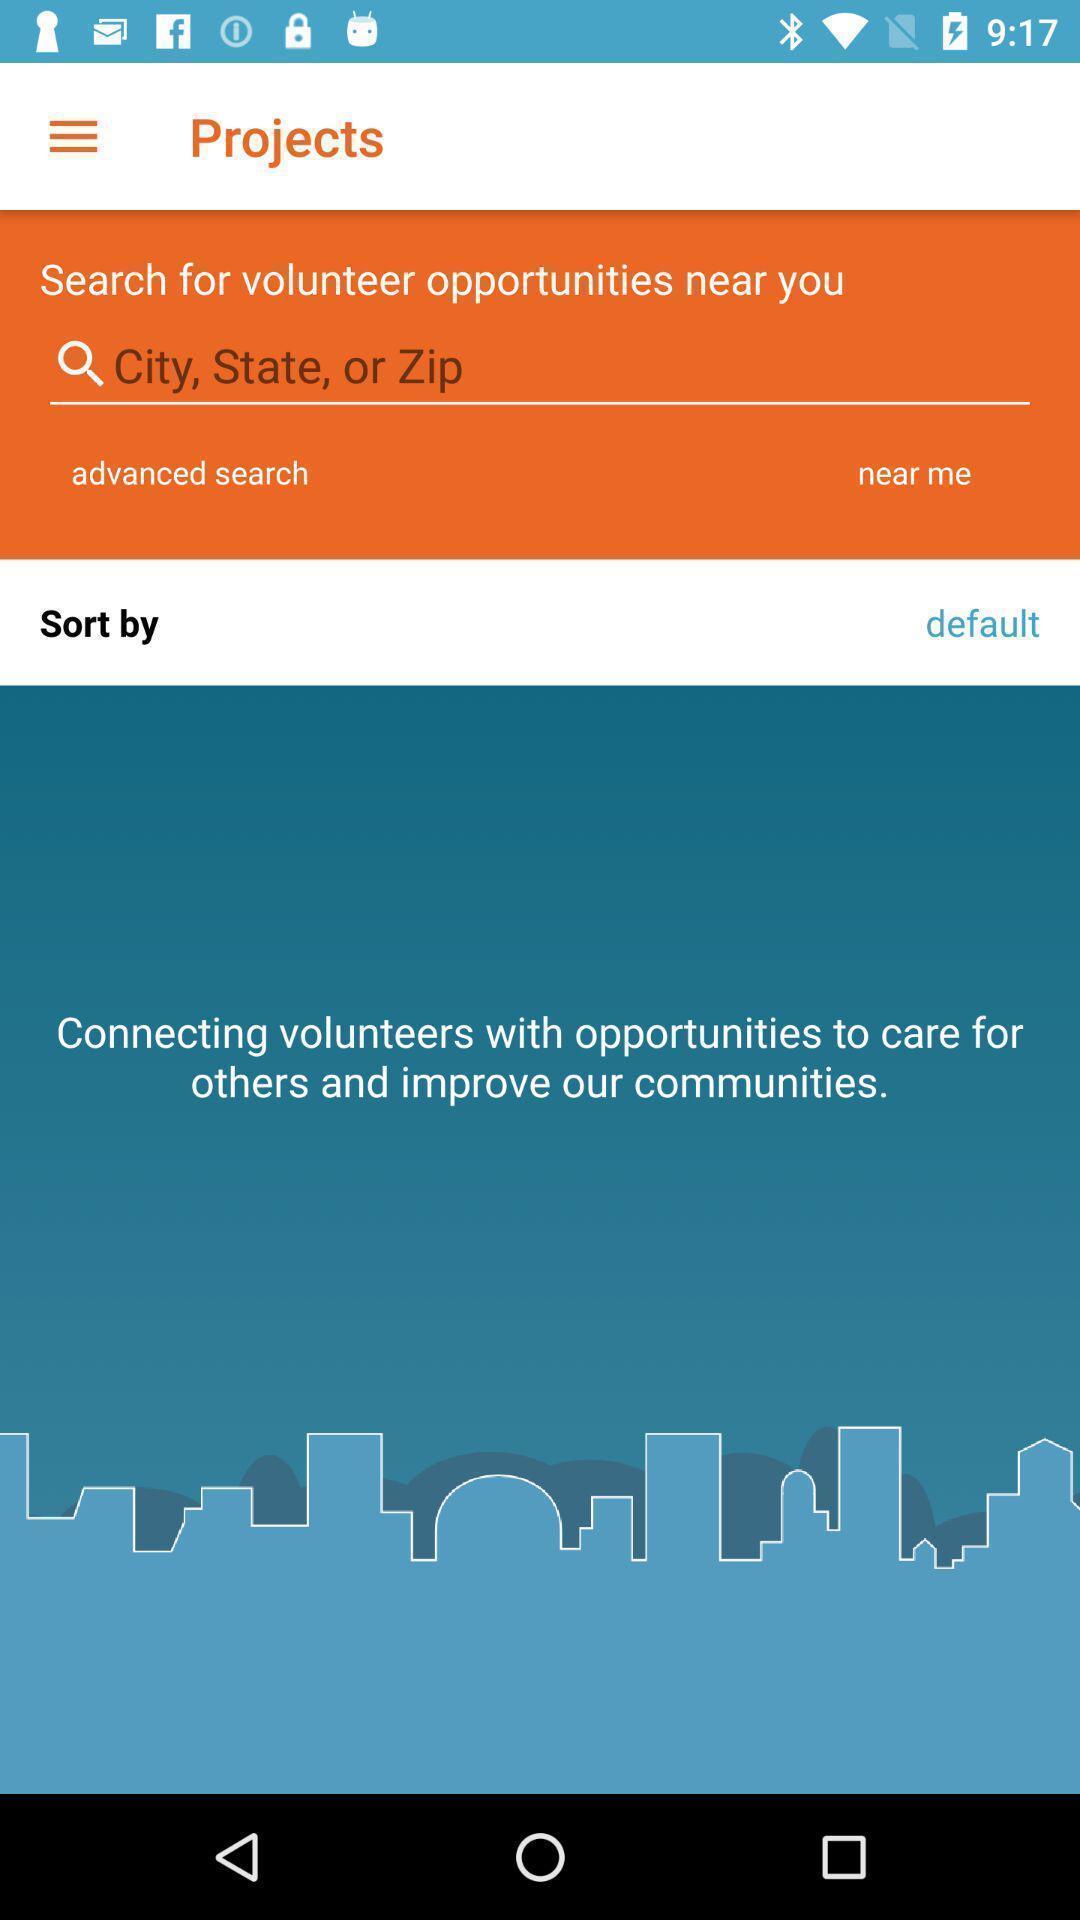Provide a description of this screenshot. Window displayed is to find opportunities. 